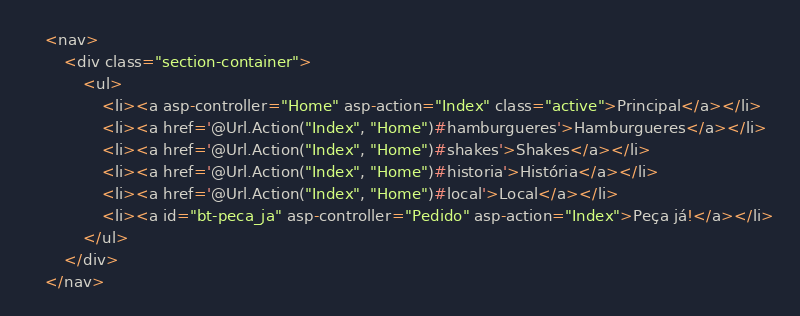<code> <loc_0><loc_0><loc_500><loc_500><_C#_>    <nav>
        <div class="section-container">
            <ul>
                <li><a asp-controller="Home" asp-action="Index" class="active">Principal</a></li>
                <li><a href='@Url.Action("Index", "Home")#hamburgueres'>Hamburgueres</a></li>
                <li><a href='@Url.Action("Index", "Home")#shakes'>Shakes</a></li>
                <li><a href='@Url.Action("Index", "Home")#historia'>História</a></li>
                <li><a href='@Url.Action("Index", "Home")#local'>Local</a></li>
                <li><a id="bt-peca_ja" asp-controller="Pedido" asp-action="Index">Peça já!</a></li>
            </ul>
        </div>
    </nav></code> 